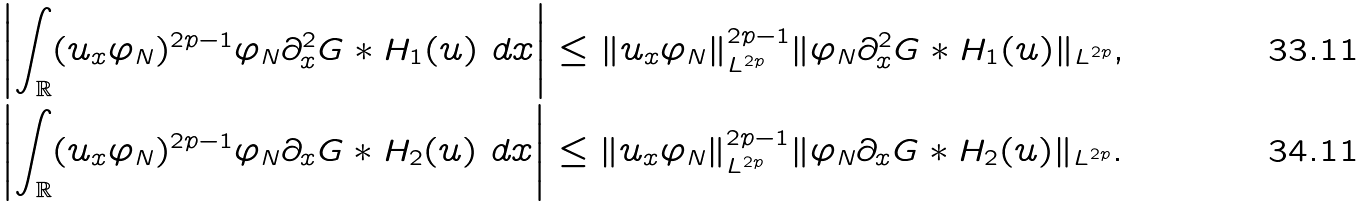<formula> <loc_0><loc_0><loc_500><loc_500>& \left | \int _ { \mathbb { R } } ( u _ { x } \varphi _ { N } ) ^ { 2 p - 1 } \varphi _ { N } \partial _ { x } ^ { 2 } G \ast H _ { 1 } ( u ) \ d x \right | \leq \| u _ { x } \varphi _ { N } \| ^ { 2 p - 1 } _ { L ^ { 2 p } } \| \varphi _ { N } \partial _ { x } ^ { 2 } G \ast H _ { 1 } ( u ) \| _ { L ^ { 2 p } } , \\ & \left | \int _ { \mathbb { R } } ( u _ { x } \varphi _ { N } ) ^ { 2 p - 1 } \varphi _ { N } \partial _ { x } G \ast H _ { 2 } ( u ) \ d x \right | \leq \| u _ { x } \varphi _ { N } \| ^ { 2 p - 1 } _ { L ^ { 2 p } } \| \varphi _ { N } \partial _ { x } G \ast H _ { 2 } ( u ) \| _ { L ^ { 2 p } } .</formula> 